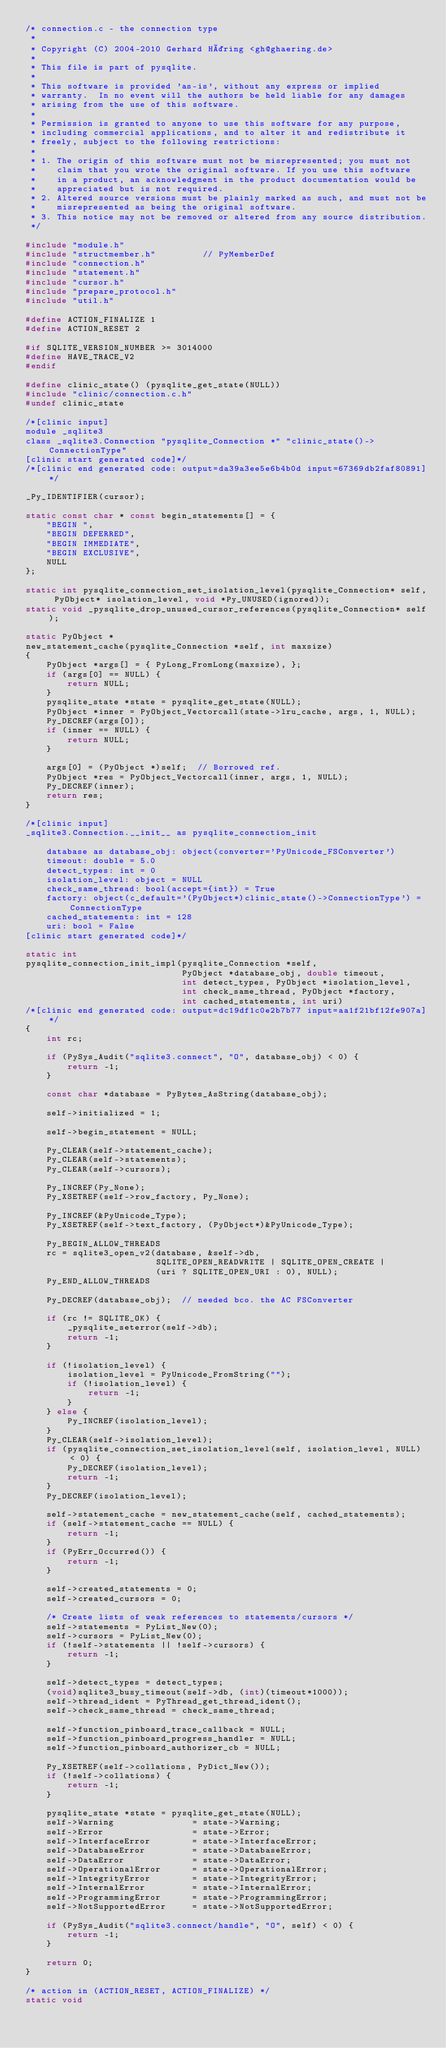<code> <loc_0><loc_0><loc_500><loc_500><_C_>/* connection.c - the connection type
 *
 * Copyright (C) 2004-2010 Gerhard Häring <gh@ghaering.de>
 *
 * This file is part of pysqlite.
 *
 * This software is provided 'as-is', without any express or implied
 * warranty.  In no event will the authors be held liable for any damages
 * arising from the use of this software.
 *
 * Permission is granted to anyone to use this software for any purpose,
 * including commercial applications, and to alter it and redistribute it
 * freely, subject to the following restrictions:
 *
 * 1. The origin of this software must not be misrepresented; you must not
 *    claim that you wrote the original software. If you use this software
 *    in a product, an acknowledgment in the product documentation would be
 *    appreciated but is not required.
 * 2. Altered source versions must be plainly marked as such, and must not be
 *    misrepresented as being the original software.
 * 3. This notice may not be removed or altered from any source distribution.
 */

#include "module.h"
#include "structmember.h"         // PyMemberDef
#include "connection.h"
#include "statement.h"
#include "cursor.h"
#include "prepare_protocol.h"
#include "util.h"

#define ACTION_FINALIZE 1
#define ACTION_RESET 2

#if SQLITE_VERSION_NUMBER >= 3014000
#define HAVE_TRACE_V2
#endif

#define clinic_state() (pysqlite_get_state(NULL))
#include "clinic/connection.c.h"
#undef clinic_state

/*[clinic input]
module _sqlite3
class _sqlite3.Connection "pysqlite_Connection *" "clinic_state()->ConnectionType"
[clinic start generated code]*/
/*[clinic end generated code: output=da39a3ee5e6b4b0d input=67369db2faf80891]*/

_Py_IDENTIFIER(cursor);

static const char * const begin_statements[] = {
    "BEGIN ",
    "BEGIN DEFERRED",
    "BEGIN IMMEDIATE",
    "BEGIN EXCLUSIVE",
    NULL
};

static int pysqlite_connection_set_isolation_level(pysqlite_Connection* self, PyObject* isolation_level, void *Py_UNUSED(ignored));
static void _pysqlite_drop_unused_cursor_references(pysqlite_Connection* self);

static PyObject *
new_statement_cache(pysqlite_Connection *self, int maxsize)
{
    PyObject *args[] = { PyLong_FromLong(maxsize), };
    if (args[0] == NULL) {
        return NULL;
    }
    pysqlite_state *state = pysqlite_get_state(NULL);
    PyObject *inner = PyObject_Vectorcall(state->lru_cache, args, 1, NULL);
    Py_DECREF(args[0]);
    if (inner == NULL) {
        return NULL;
    }

    args[0] = (PyObject *)self;  // Borrowed ref.
    PyObject *res = PyObject_Vectorcall(inner, args, 1, NULL);
    Py_DECREF(inner);
    return res;
}

/*[clinic input]
_sqlite3.Connection.__init__ as pysqlite_connection_init

    database as database_obj: object(converter='PyUnicode_FSConverter')
    timeout: double = 5.0
    detect_types: int = 0
    isolation_level: object = NULL
    check_same_thread: bool(accept={int}) = True
    factory: object(c_default='(PyObject*)clinic_state()->ConnectionType') = ConnectionType
    cached_statements: int = 128
    uri: bool = False
[clinic start generated code]*/

static int
pysqlite_connection_init_impl(pysqlite_Connection *self,
                              PyObject *database_obj, double timeout,
                              int detect_types, PyObject *isolation_level,
                              int check_same_thread, PyObject *factory,
                              int cached_statements, int uri)
/*[clinic end generated code: output=dc19df1c0e2b7b77 input=aa1f21bf12fe907a]*/
{
    int rc;

    if (PySys_Audit("sqlite3.connect", "O", database_obj) < 0) {
        return -1;
    }

    const char *database = PyBytes_AsString(database_obj);

    self->initialized = 1;

    self->begin_statement = NULL;

    Py_CLEAR(self->statement_cache);
    Py_CLEAR(self->statements);
    Py_CLEAR(self->cursors);

    Py_INCREF(Py_None);
    Py_XSETREF(self->row_factory, Py_None);

    Py_INCREF(&PyUnicode_Type);
    Py_XSETREF(self->text_factory, (PyObject*)&PyUnicode_Type);

    Py_BEGIN_ALLOW_THREADS
    rc = sqlite3_open_v2(database, &self->db,
                         SQLITE_OPEN_READWRITE | SQLITE_OPEN_CREATE |
                         (uri ? SQLITE_OPEN_URI : 0), NULL);
    Py_END_ALLOW_THREADS

    Py_DECREF(database_obj);  // needed bco. the AC FSConverter

    if (rc != SQLITE_OK) {
        _pysqlite_seterror(self->db);
        return -1;
    }

    if (!isolation_level) {
        isolation_level = PyUnicode_FromString("");
        if (!isolation_level) {
            return -1;
        }
    } else {
        Py_INCREF(isolation_level);
    }
    Py_CLEAR(self->isolation_level);
    if (pysqlite_connection_set_isolation_level(self, isolation_level, NULL) < 0) {
        Py_DECREF(isolation_level);
        return -1;
    }
    Py_DECREF(isolation_level);

    self->statement_cache = new_statement_cache(self, cached_statements);
    if (self->statement_cache == NULL) {
        return -1;
    }
    if (PyErr_Occurred()) {
        return -1;
    }

    self->created_statements = 0;
    self->created_cursors = 0;

    /* Create lists of weak references to statements/cursors */
    self->statements = PyList_New(0);
    self->cursors = PyList_New(0);
    if (!self->statements || !self->cursors) {
        return -1;
    }

    self->detect_types = detect_types;
    (void)sqlite3_busy_timeout(self->db, (int)(timeout*1000));
    self->thread_ident = PyThread_get_thread_ident();
    self->check_same_thread = check_same_thread;

    self->function_pinboard_trace_callback = NULL;
    self->function_pinboard_progress_handler = NULL;
    self->function_pinboard_authorizer_cb = NULL;

    Py_XSETREF(self->collations, PyDict_New());
    if (!self->collations) {
        return -1;
    }

    pysqlite_state *state = pysqlite_get_state(NULL);
    self->Warning               = state->Warning;
    self->Error                 = state->Error;
    self->InterfaceError        = state->InterfaceError;
    self->DatabaseError         = state->DatabaseError;
    self->DataError             = state->DataError;
    self->OperationalError      = state->OperationalError;
    self->IntegrityError        = state->IntegrityError;
    self->InternalError         = state->InternalError;
    self->ProgrammingError      = state->ProgrammingError;
    self->NotSupportedError     = state->NotSupportedError;

    if (PySys_Audit("sqlite3.connect/handle", "O", self) < 0) {
        return -1;
    }

    return 0;
}

/* action in (ACTION_RESET, ACTION_FINALIZE) */
static void</code> 